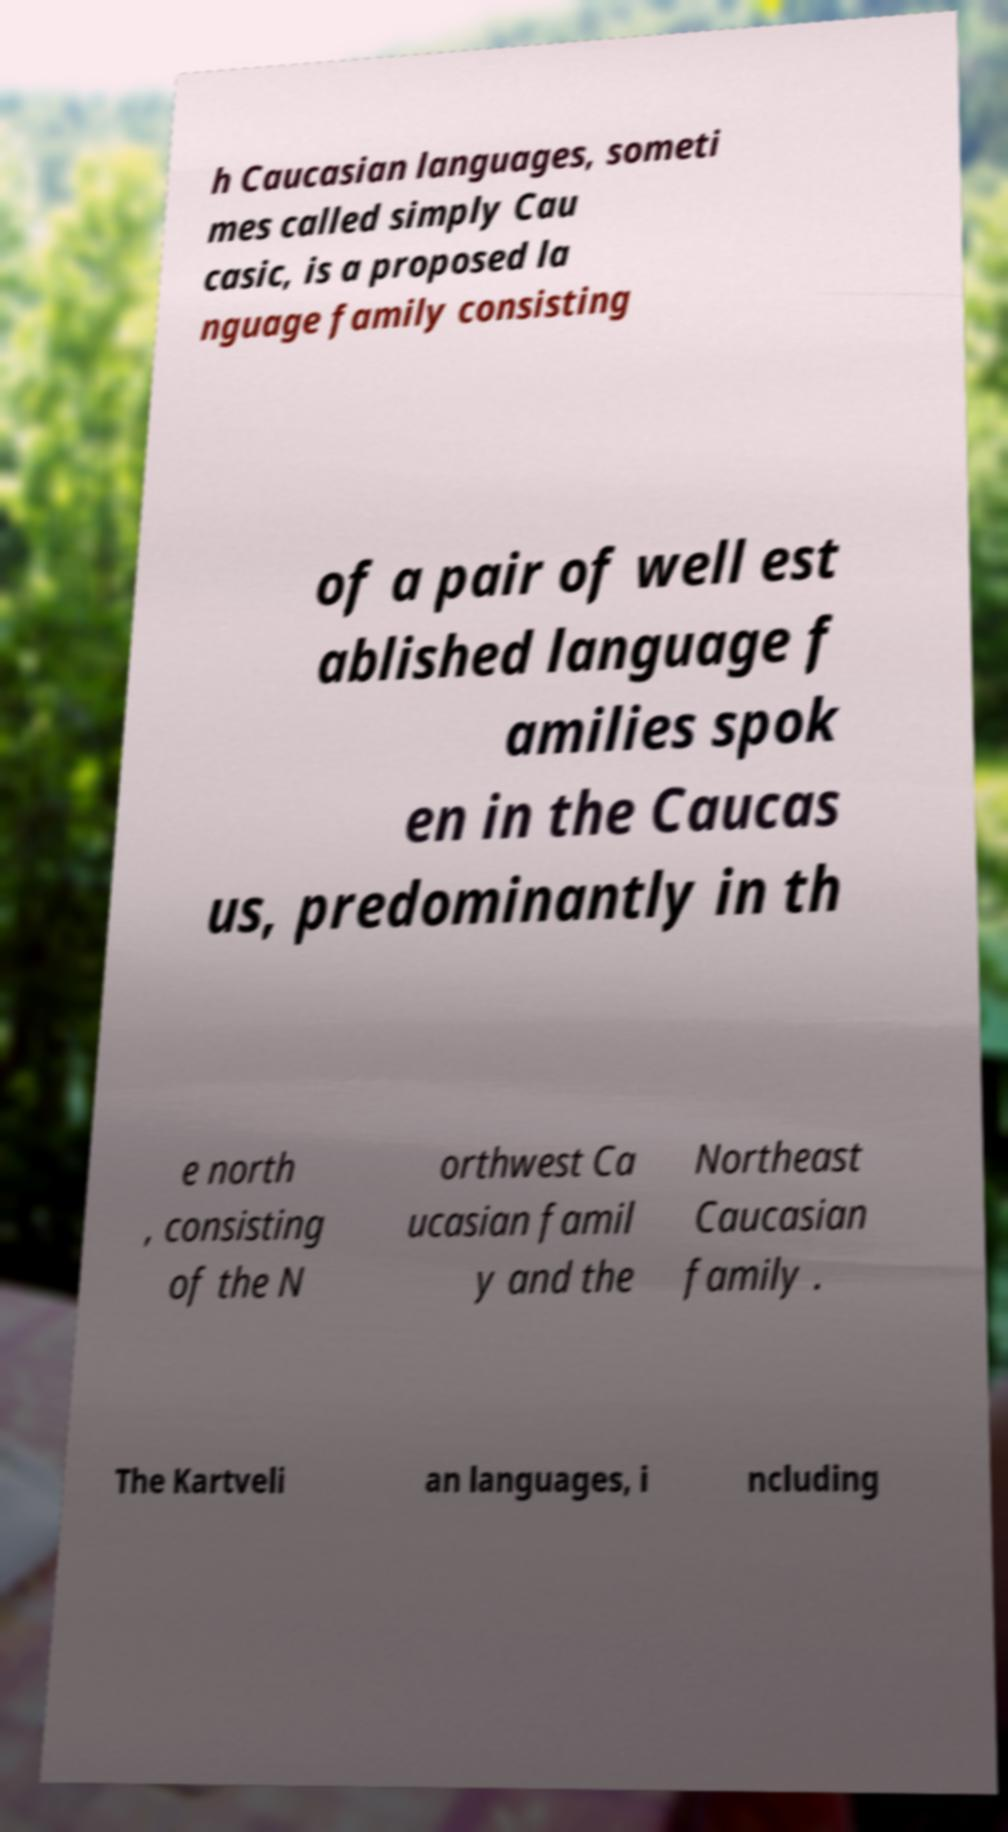For documentation purposes, I need the text within this image transcribed. Could you provide that? h Caucasian languages, someti mes called simply Cau casic, is a proposed la nguage family consisting of a pair of well est ablished language f amilies spok en in the Caucas us, predominantly in th e north , consisting of the N orthwest Ca ucasian famil y and the Northeast Caucasian family . The Kartveli an languages, i ncluding 